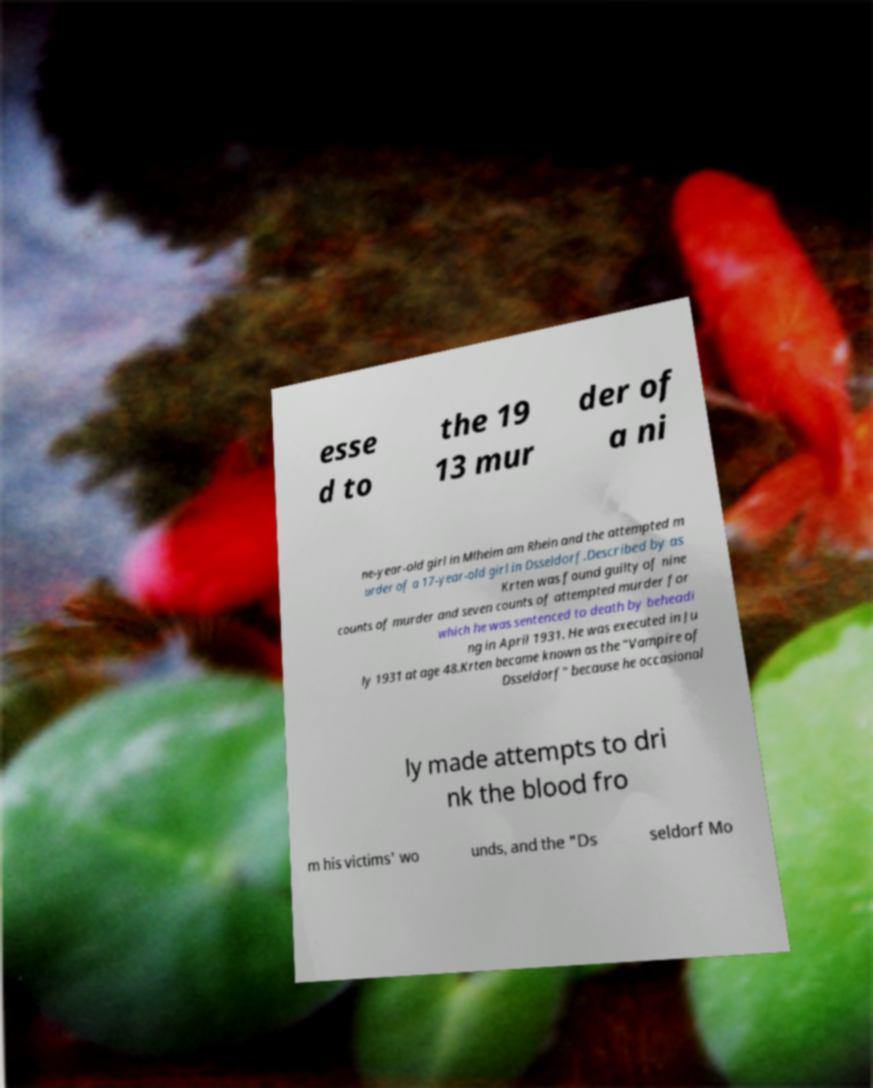Can you accurately transcribe the text from the provided image for me? esse d to the 19 13 mur der of a ni ne-year-old girl in Mlheim am Rhein and the attempted m urder of a 17-year-old girl in Dsseldorf.Described by as Krten was found guilty of nine counts of murder and seven counts of attempted murder for which he was sentenced to death by beheadi ng in April 1931. He was executed in Ju ly 1931 at age 48.Krten became known as the "Vampire of Dsseldorf" because he occasional ly made attempts to dri nk the blood fro m his victims' wo unds, and the "Ds seldorf Mo 